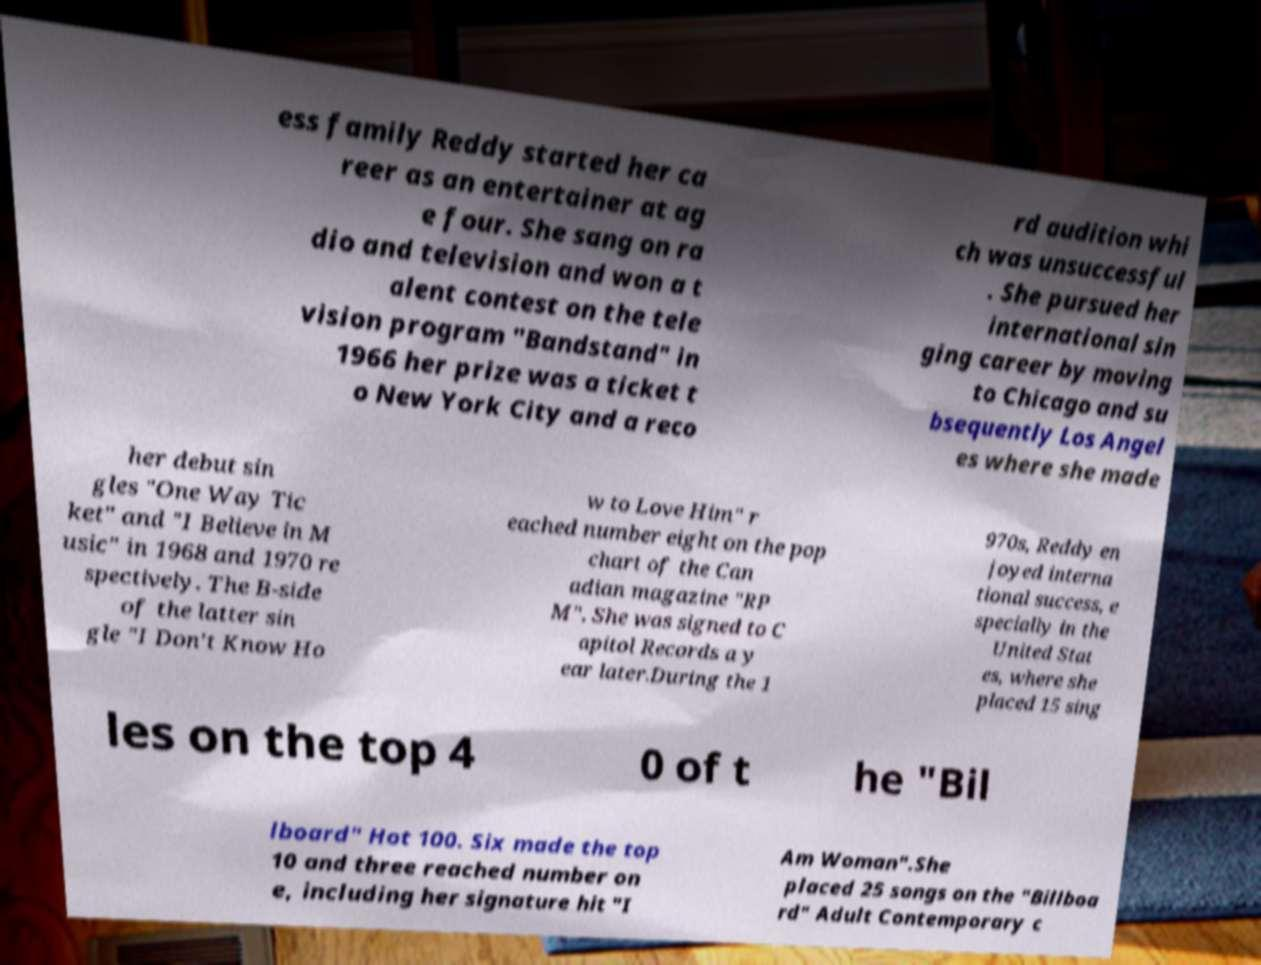Please identify and transcribe the text found in this image. ess family Reddy started her ca reer as an entertainer at ag e four. She sang on ra dio and television and won a t alent contest on the tele vision program "Bandstand" in 1966 her prize was a ticket t o New York City and a reco rd audition whi ch was unsuccessful . She pursued her international sin ging career by moving to Chicago and su bsequently Los Angel es where she made her debut sin gles "One Way Tic ket" and "I Believe in M usic" in 1968 and 1970 re spectively. The B-side of the latter sin gle "I Don't Know Ho w to Love Him" r eached number eight on the pop chart of the Can adian magazine "RP M". She was signed to C apitol Records a y ear later.During the 1 970s, Reddy en joyed interna tional success, e specially in the United Stat es, where she placed 15 sing les on the top 4 0 of t he "Bil lboard" Hot 100. Six made the top 10 and three reached number on e, including her signature hit "I Am Woman".She placed 25 songs on the "Billboa rd" Adult Contemporary c 